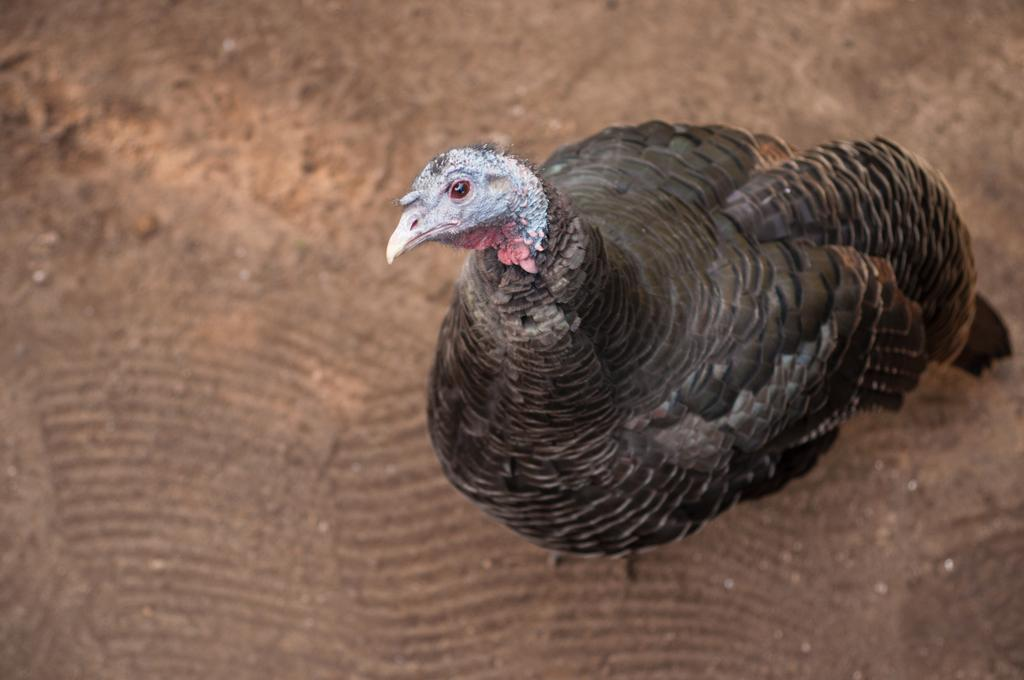What type of animal is present in the image? There is a bird in the image. What color is the bird? The bird is black in color. What is the weight of the plate that the bird is sitting on in the image? There is no plate present in the image, and therefore no weight can be determined. 